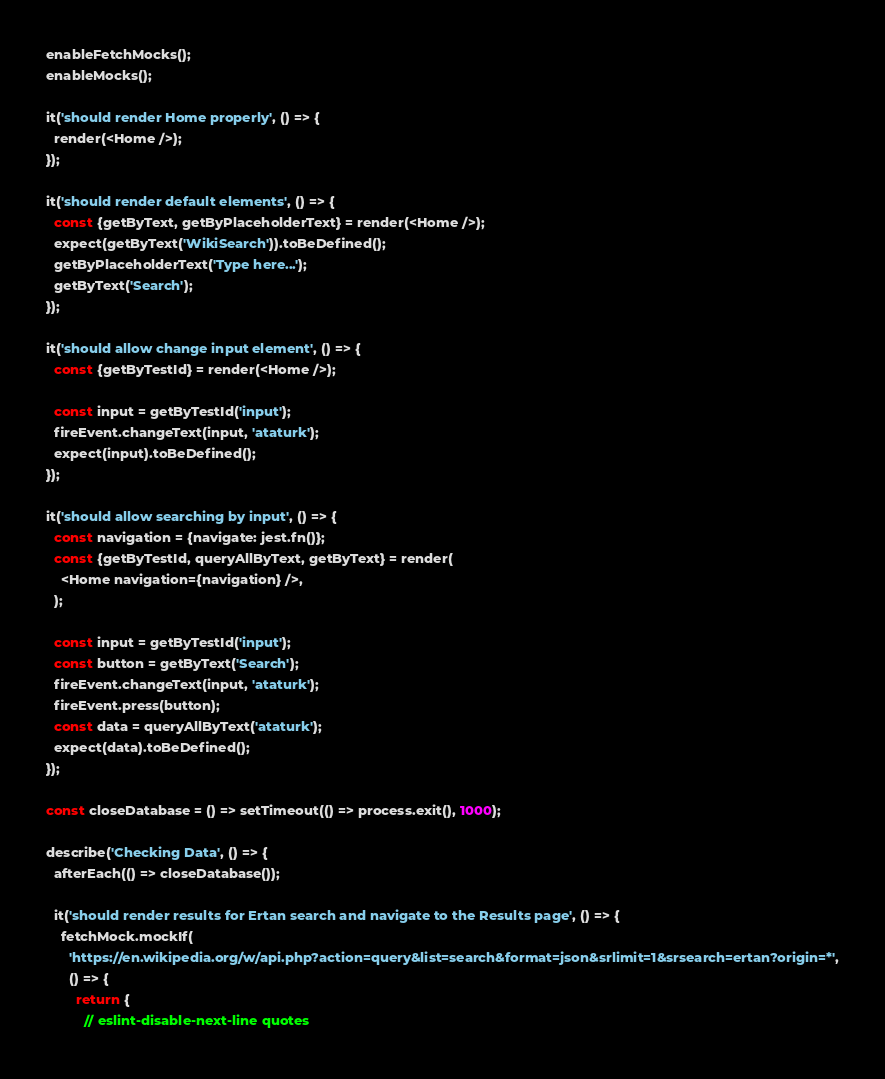<code> <loc_0><loc_0><loc_500><loc_500><_JavaScript_>
enableFetchMocks();
enableMocks();

it('should render Home properly', () => {
  render(<Home />);
});

it('should render default elements', () => {
  const {getByText, getByPlaceholderText} = render(<Home />);
  expect(getByText('WikiSearch')).toBeDefined();
  getByPlaceholderText('Type here...');
  getByText('Search');
});

it('should allow change input element', () => {
  const {getByTestId} = render(<Home />);

  const input = getByTestId('input');
  fireEvent.changeText(input, 'ataturk');
  expect(input).toBeDefined();
});

it('should allow searching by input', () => {
  const navigation = {navigate: jest.fn()};
  const {getByTestId, queryAllByText, getByText} = render(
    <Home navigation={navigation} />,
  );

  const input = getByTestId('input');
  const button = getByText('Search');
  fireEvent.changeText(input, 'ataturk');
  fireEvent.press(button);
  const data = queryAllByText('ataturk');
  expect(data).toBeDefined();
});

const closeDatabase = () => setTimeout(() => process.exit(), 1000);

describe('Checking Data', () => {
  afterEach(() => closeDatabase());

  it('should render results for Ertan search and navigate to the Results page', () => {
    fetchMock.mockIf(
      'https://en.wikipedia.org/w/api.php?action=query&list=search&format=json&srlimit=1&srsearch=ertan?origin=*',
      () => {
        return {
          // eslint-disable-next-line quotes</code> 